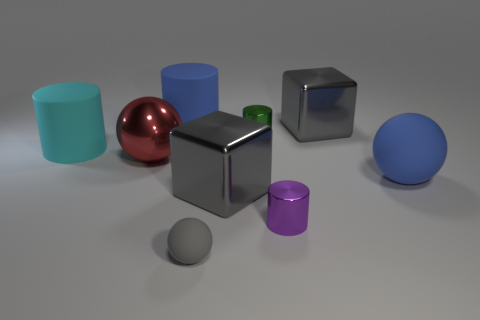Subtract all blue rubber cylinders. How many cylinders are left? 3 Add 1 green metal cylinders. How many objects exist? 10 Subtract all cyan cylinders. How many cylinders are left? 3 Subtract all cubes. How many objects are left? 7 Add 8 green shiny objects. How many green shiny objects are left? 9 Add 1 gray rubber cylinders. How many gray rubber cylinders exist? 1 Subtract 1 green cylinders. How many objects are left? 8 Subtract 1 blocks. How many blocks are left? 1 Subtract all cyan cylinders. Subtract all yellow spheres. How many cylinders are left? 3 Subtract all gray balls. How many purple cylinders are left? 1 